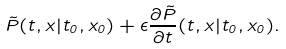<formula> <loc_0><loc_0><loc_500><loc_500>\tilde { P } ( t , x | t _ { 0 } , x _ { 0 } ) + \epsilon \frac { \partial \tilde { P } } { \partial t } ( t , x | t _ { 0 } , x _ { 0 } ) .</formula> 